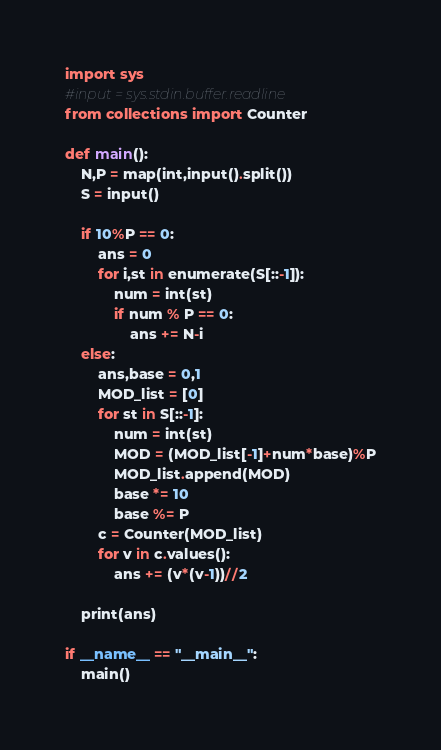Convert code to text. <code><loc_0><loc_0><loc_500><loc_500><_Python_>import sys
#input = sys.stdin.buffer.readline
from collections import Counter

def main():
    N,P = map(int,input().split())
    S = input()
    
    if 10%P == 0:
        ans = 0
        for i,st in enumerate(S[::-1]):
            num = int(st)
            if num % P == 0:
                ans += N-i
    else:
        ans,base = 0,1
        MOD_list = [0]
        for st in S[::-1]:
            num = int(st)
            MOD = (MOD_list[-1]+num*base)%P
            MOD_list.append(MOD)
            base *= 10
            base %= P
        c = Counter(MOD_list)
        for v in c.values():
            ans += (v*(v-1))//2
        
    print(ans)

if __name__ == "__main__":
    main()
</code> 